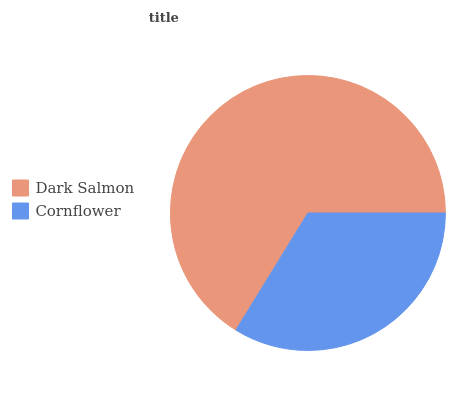Is Cornflower the minimum?
Answer yes or no. Yes. Is Dark Salmon the maximum?
Answer yes or no. Yes. Is Cornflower the maximum?
Answer yes or no. No. Is Dark Salmon greater than Cornflower?
Answer yes or no. Yes. Is Cornflower less than Dark Salmon?
Answer yes or no. Yes. Is Cornflower greater than Dark Salmon?
Answer yes or no. No. Is Dark Salmon less than Cornflower?
Answer yes or no. No. Is Dark Salmon the high median?
Answer yes or no. Yes. Is Cornflower the low median?
Answer yes or no. Yes. Is Cornflower the high median?
Answer yes or no. No. Is Dark Salmon the low median?
Answer yes or no. No. 